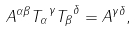Convert formula to latex. <formula><loc_0><loc_0><loc_500><loc_500>A ^ { \alpha \beta } { T _ { \alpha } } ^ { \gamma } { T _ { \beta } } ^ { \delta } = A ^ { \gamma \delta } ,</formula> 